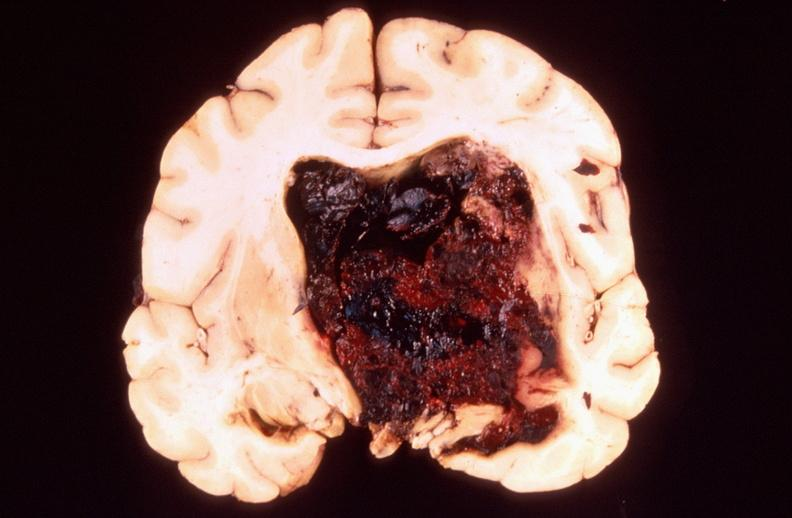does this image show brain, intracerebral hemorrhage?
Answer the question using a single word or phrase. Yes 